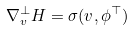Convert formula to latex. <formula><loc_0><loc_0><loc_500><loc_500>\nabla ^ { \bot } _ { v } H = \sigma ( v , \phi ^ { \top } )</formula> 